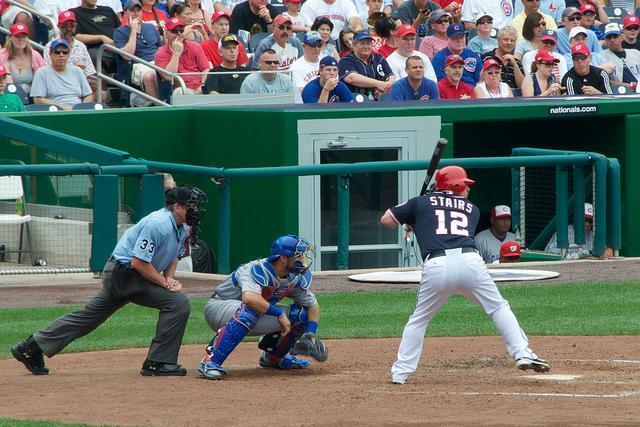What team does the catcher play for?
From the following set of four choices, select the accurate answer to respond to the question.
Options: Cubs, yankees, astros, mets. Cubs. 